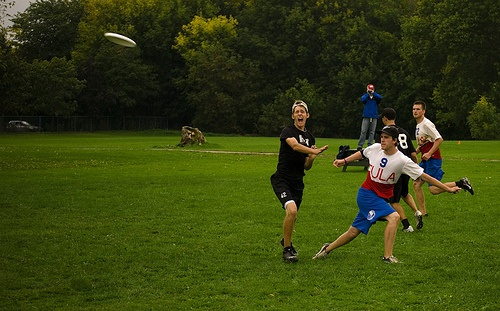Describe the objects in this image and their specific colors. I can see people in gray, navy, black, lightgray, and olive tones, people in gray, black, olive, and maroon tones, people in gray, black, olive, maroon, and navy tones, people in gray, black, navy, and darkgreen tones, and people in gray, black, ivory, maroon, and olive tones in this image. 